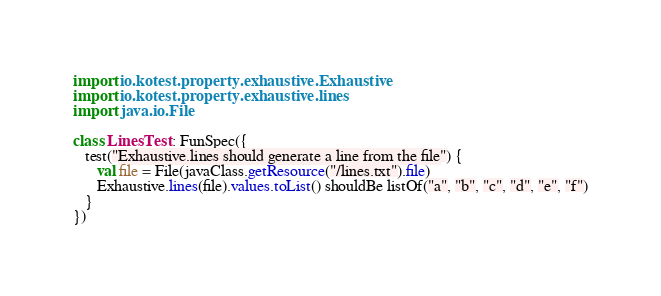Convert code to text. <code><loc_0><loc_0><loc_500><loc_500><_Kotlin_>import io.kotest.property.exhaustive.Exhaustive
import io.kotest.property.exhaustive.lines
import java.io.File

class LinesTest : FunSpec({
   test("Exhaustive.lines should generate a line from the file") {
      val file = File(javaClass.getResource("/lines.txt").file)
      Exhaustive.lines(file).values.toList() shouldBe listOf("a", "b", "c", "d", "e", "f")
   }
})
</code> 